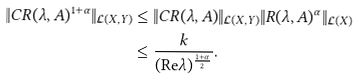<formula> <loc_0><loc_0><loc_500><loc_500>\| C R ( \lambda , A ) ^ { 1 + \alpha } \| _ { \mathcal { L } ( X , Y ) } & \leq \| C R ( \lambda , A ) \| _ { \mathcal { L } ( X , Y ) } \| R ( \lambda , A ) ^ { \alpha } \| _ { \mathcal { L } ( X ) } \\ & \leq \frac { k } { ( \text {Re} \lambda ) ^ { \frac { 1 + \alpha } { 2 } } } .</formula> 